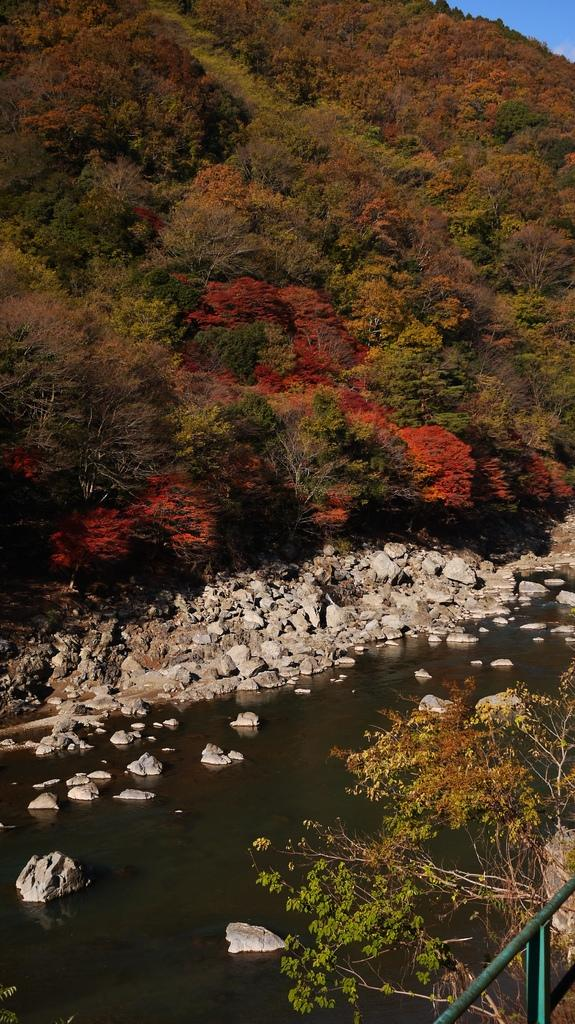What is located in the bottom right corner of the image? There are plants in the bottom right corner of the image. What can be seen in the middle of the image? There are rocks in the middle of the image. What is visible in the background of the image? The background of the image is the sky. What is the name of the alley in the image? There is no alley present in the image; it features plants, rocks, and the sky. What type of station is visible in the image? There is no station present in the image; it features plants, rocks, and the sky. 